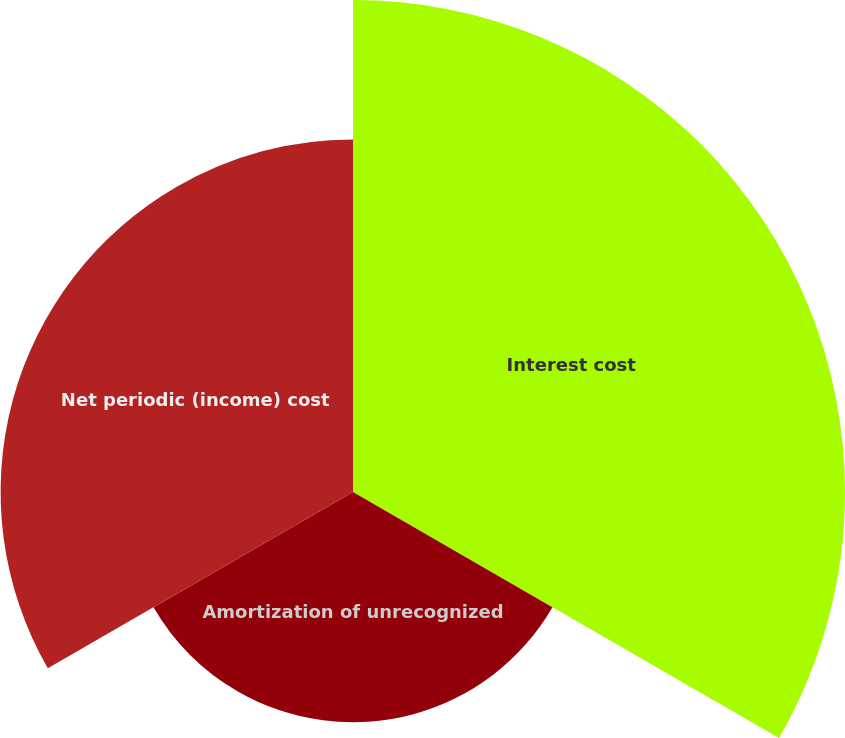Convert chart to OTSL. <chart><loc_0><loc_0><loc_500><loc_500><pie_chart><fcel>Interest cost<fcel>Amortization of unrecognized<fcel>Net periodic (income) cost<nl><fcel>45.78%<fcel>21.43%<fcel>32.79%<nl></chart> 